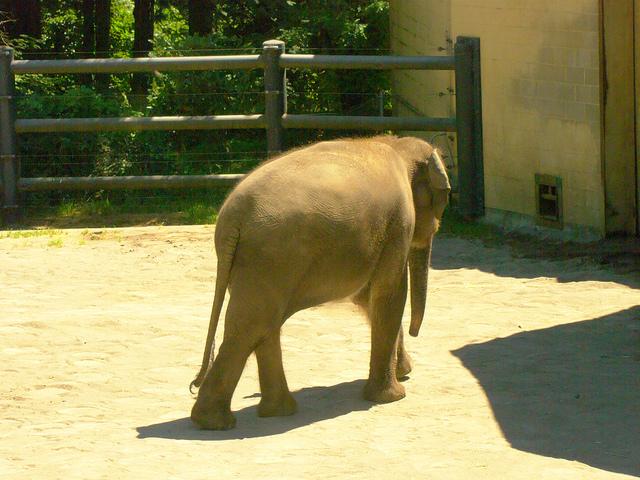What kind of bars?
Answer briefly. Wood. How many horizontal bars?
Be succinct. 3. Is this a full grown elephant?
Quick response, please. No. 